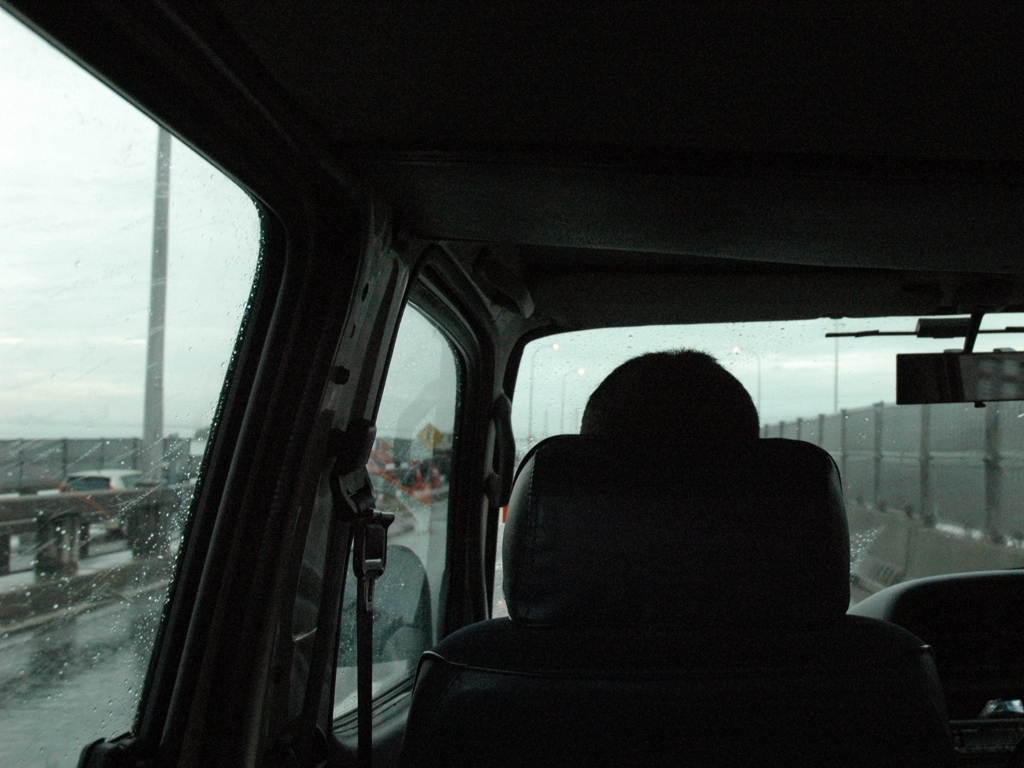What might be the reasons for traveling in such conditions? Potential reasons could include commuting to work, returning home, or traveling for urgent matters. The necessity of travel despite the weather may emphasize the routine or commitment in the subject's life. Could there be a symbolic interpretation of this journey? Symbolically, the journey amidst rain could represent persistence through challenges, a personal transformation, or the contemplation of life's ephemerality. It might also reflect a scenario of moving forward despite difficulties or uncertainties. 